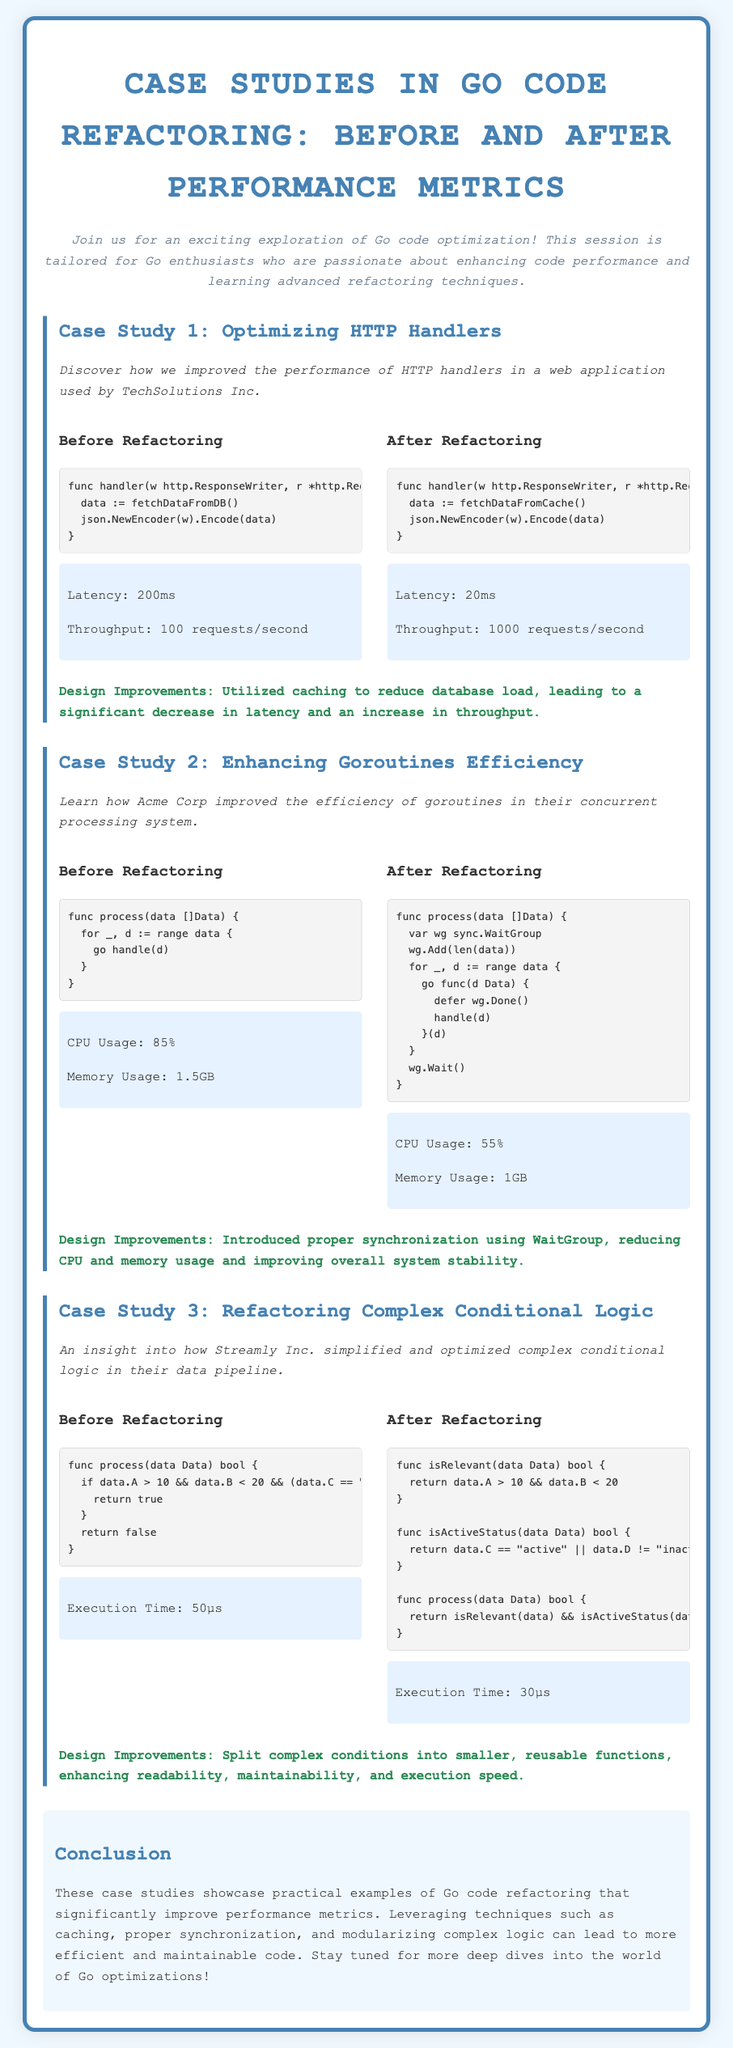What is the title of the document? The title of the document is stated prominently at the top of the Playbill in the header section.
Answer: Case Studies in Go Code Refactoring: Before and After Performance Metrics What company is associated with the first case study? The first case study mentions a specific company that benefited from the performance improvements described.
Answer: TechSolutions Inc What is the latency after refactoring in Case Study 1? The latency metrics after refactoring in Case Study 1 provide a specific value indicating the performance improvement.
Answer: 20ms What is the execution time before refactoring in Case Study 3? The execution time before refactoring is specified in the metrics of Case Study 3.
Answer: 50µs Which design improvement is noted in Case Study 2? The case study describes a specific design improvement that enhanced system performance and resource usage.
Answer: Proper synchronization using WaitGroup What category does the third case study focus on? The third case study indicates the specific area of code refactoring being analyzed, which is a common situation in software development.
Answer: Complex Conditional Logic How many requests per second can the optimized HTTP handler handle? The throughput metrics after refactoring give a concrete number of requests that can be handled efficiently.
Answer: 1000 requests/second What is the CPU usage after refactoring in Case Study 2? The metrics after refactoring provide specific performance details about CPU utilization.
Answer: 55% 